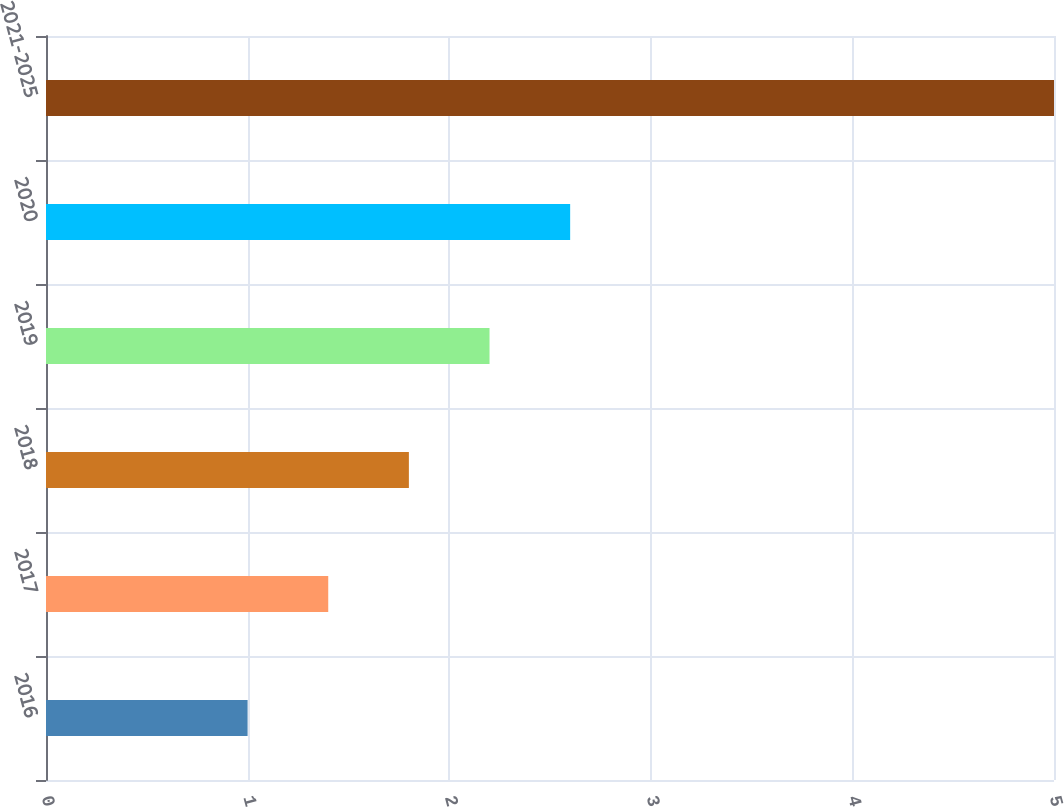<chart> <loc_0><loc_0><loc_500><loc_500><bar_chart><fcel>2016<fcel>2017<fcel>2018<fcel>2019<fcel>2020<fcel>2021-2025<nl><fcel>1<fcel>1.4<fcel>1.8<fcel>2.2<fcel>2.6<fcel>5<nl></chart> 